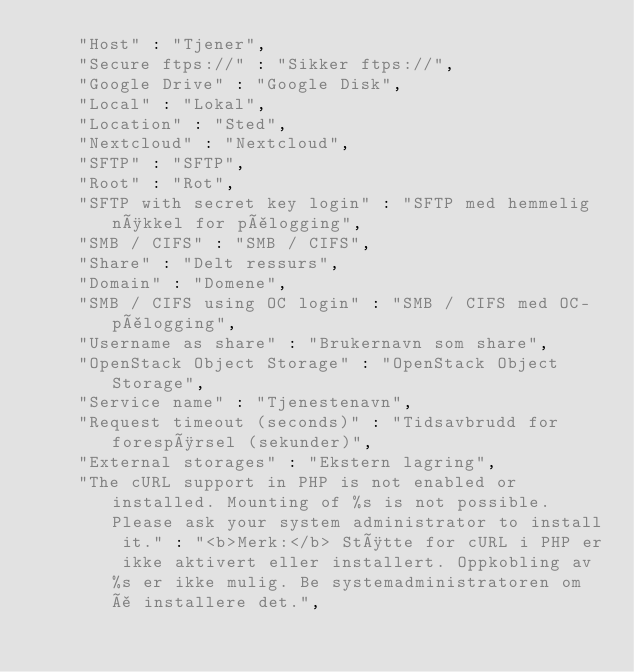<code> <loc_0><loc_0><loc_500><loc_500><_JavaScript_>    "Host" : "Tjener",
    "Secure ftps://" : "Sikker ftps://",
    "Google Drive" : "Google Disk",
    "Local" : "Lokal",
    "Location" : "Sted",
    "Nextcloud" : "Nextcloud",
    "SFTP" : "SFTP",
    "Root" : "Rot",
    "SFTP with secret key login" : "SFTP med hemmelig nøkkel for pålogging",
    "SMB / CIFS" : "SMB / CIFS",
    "Share" : "Delt ressurs",
    "Domain" : "Domene",
    "SMB / CIFS using OC login" : "SMB / CIFS med OC-pålogging",
    "Username as share" : "Brukernavn som share",
    "OpenStack Object Storage" : "OpenStack Object Storage",
    "Service name" : "Tjenestenavn",
    "Request timeout (seconds)" : "Tidsavbrudd for forespørsel (sekunder)",
    "External storages" : "Ekstern lagring",
    "The cURL support in PHP is not enabled or installed. Mounting of %s is not possible. Please ask your system administrator to install it." : "<b>Merk:</b> Støtte for cURL i PHP er ikke aktivert eller installert. Oppkobling av %s er ikke mulig. Be systemadministratoren om å installere det.",</code> 